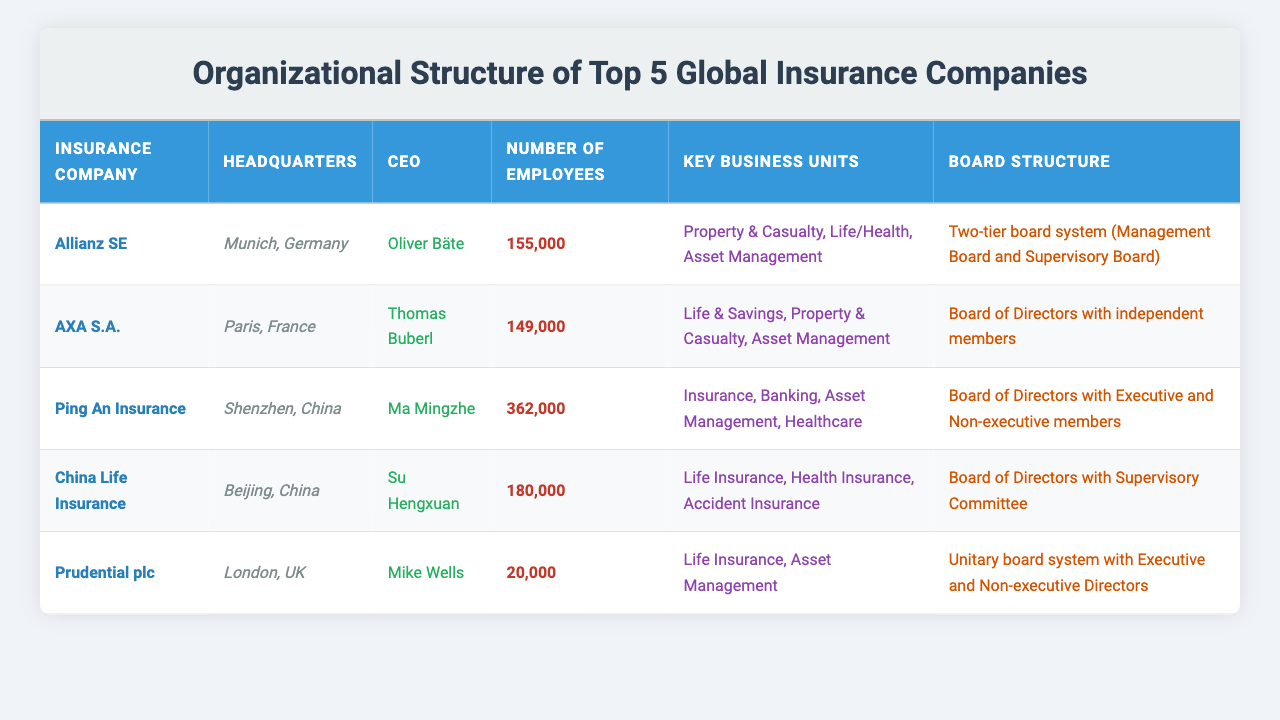What is the headquarters location of Allianz SE? The table lists Allianz SE's headquarters as "Munich, Germany."
Answer: Munich, Germany Who is the CEO of AXA S.A.? According to the table, the CEO of AXA S.A. is "Thomas Buberl."
Answer: Thomas Buberl How many employees does Ping An Insurance have? The table provides the number of employees for Ping An Insurance as "362,000."
Answer: 362,000 What are the key business units of China Life Insurance? The key business units listed for China Life Insurance in the table are "Life Insurance, Health Insurance, Accident Insurance."
Answer: Life Insurance, Health Insurance, Accident Insurance Does Prudential plc have a unitary board system? The table states that Prudential plc uses a "Unitary board system with Executive and Non-executive Directors," which confirms that it does have such a structure.
Answer: Yes Which company has the most employees? Comparing the number of employees for each company, Ping An Insurance has "362,000," which is higher than all others.
Answer: Ping An Insurance What is the total number of employees for Allianz SE and AXA S.A.? To find the total, we sum the number of employees: 155,000 (Allianz SE) + 149,000 (AXA S.A.) = 304,000.
Answer: 304,000 Is the headquarters of Prudential plc located in the UK? The table indicates that Prudential plc's headquarters is in "London, UK," confirming it is located there.
Answer: Yes Which company has a two-tier board system? The table mentions that Allianz SE has a "Two-tier board system (Management Board and Supervisory Board)."
Answer: Allianz SE What is the difference in the number of employees between Ping An Insurance and Prudential plc? To find the difference, we calculate: 362,000 (Ping An) - 20,000 (Prudential) = 342,000.
Answer: 342,000 